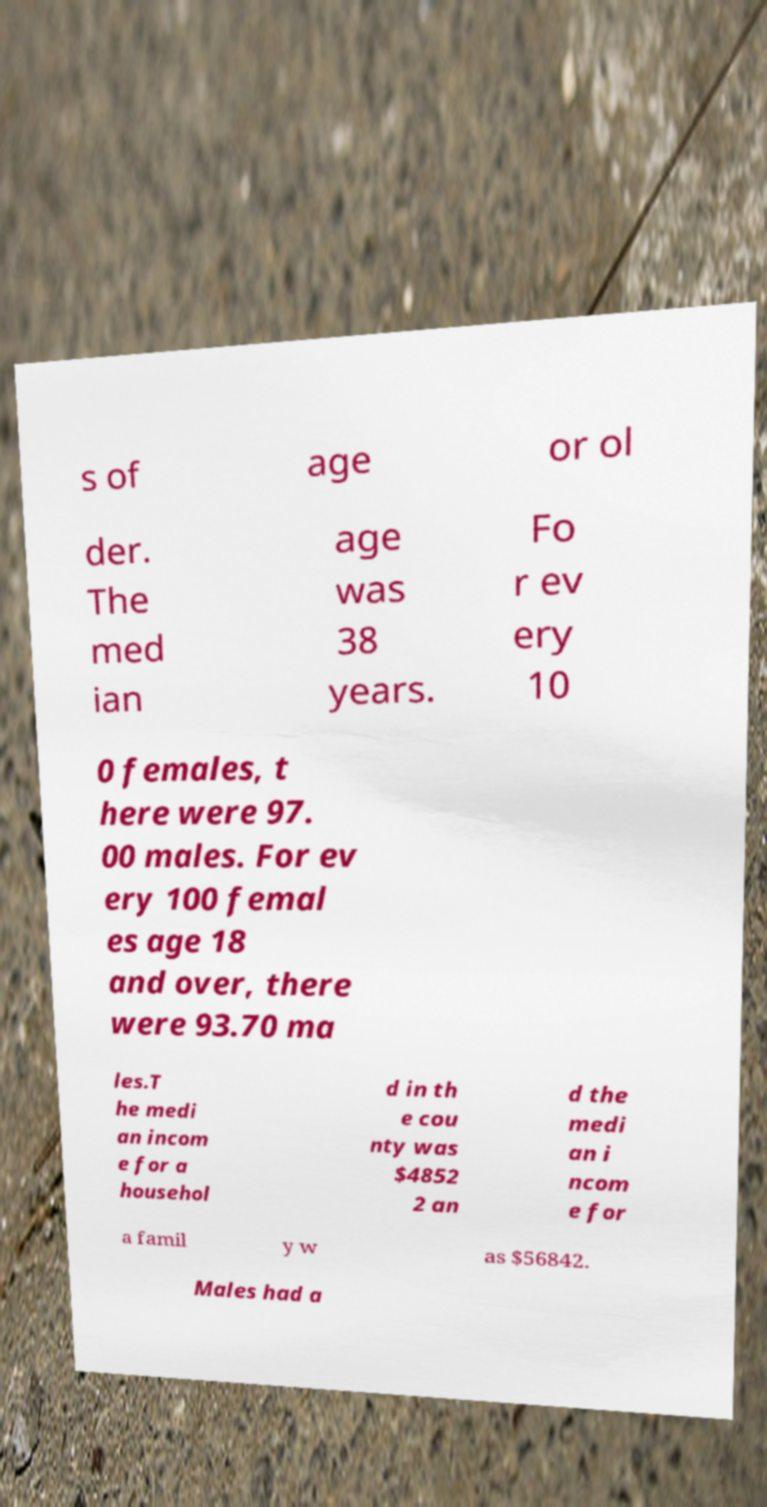Could you extract and type out the text from this image? s of age or ol der. The med ian age was 38 years. Fo r ev ery 10 0 females, t here were 97. 00 males. For ev ery 100 femal es age 18 and over, there were 93.70 ma les.T he medi an incom e for a househol d in th e cou nty was $4852 2 an d the medi an i ncom e for a famil y w as $56842. Males had a 